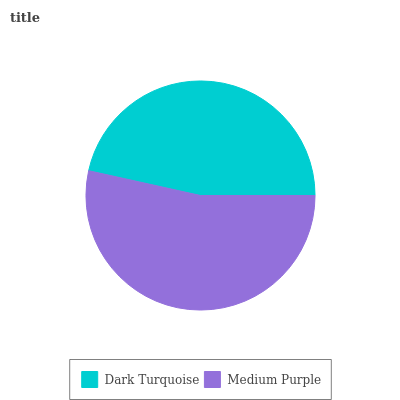Is Dark Turquoise the minimum?
Answer yes or no. Yes. Is Medium Purple the maximum?
Answer yes or no. Yes. Is Medium Purple the minimum?
Answer yes or no. No. Is Medium Purple greater than Dark Turquoise?
Answer yes or no. Yes. Is Dark Turquoise less than Medium Purple?
Answer yes or no. Yes. Is Dark Turquoise greater than Medium Purple?
Answer yes or no. No. Is Medium Purple less than Dark Turquoise?
Answer yes or no. No. Is Medium Purple the high median?
Answer yes or no. Yes. Is Dark Turquoise the low median?
Answer yes or no. Yes. Is Dark Turquoise the high median?
Answer yes or no. No. Is Medium Purple the low median?
Answer yes or no. No. 